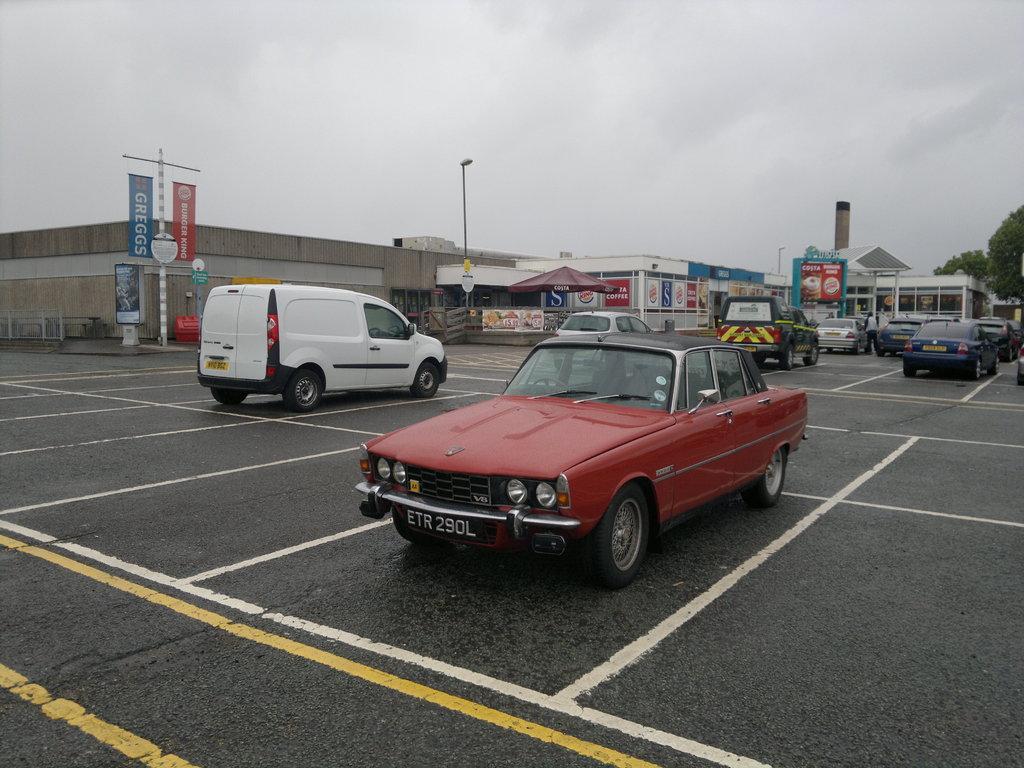Could you give a brief overview of what you see in this image? There is a road. On which, there are vehicles parked. In the background, there are hoardings, buildings, trees, poles and clouds in the sky. 